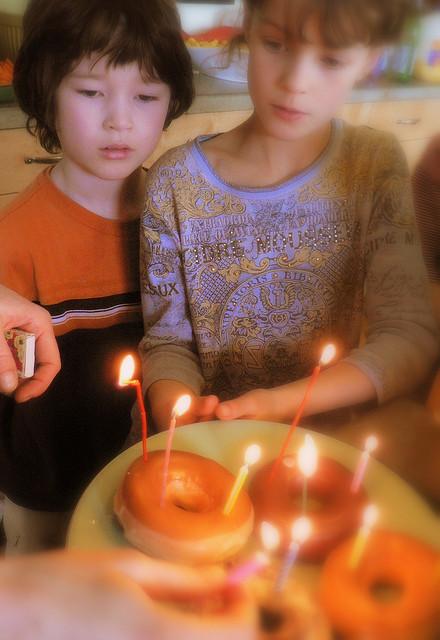What are the candles in?
Short answer required. Donuts. Are the candles lit?
Keep it brief. Yes. How many candles?
Concise answer only. 9. 